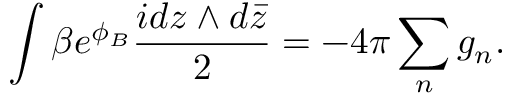<formula> <loc_0><loc_0><loc_500><loc_500>\int \beta e ^ { \phi _ { B } } \frac { i d z \wedge d \bar { z } } { 2 } = - 4 \pi \sum _ { n } g _ { n } .</formula> 